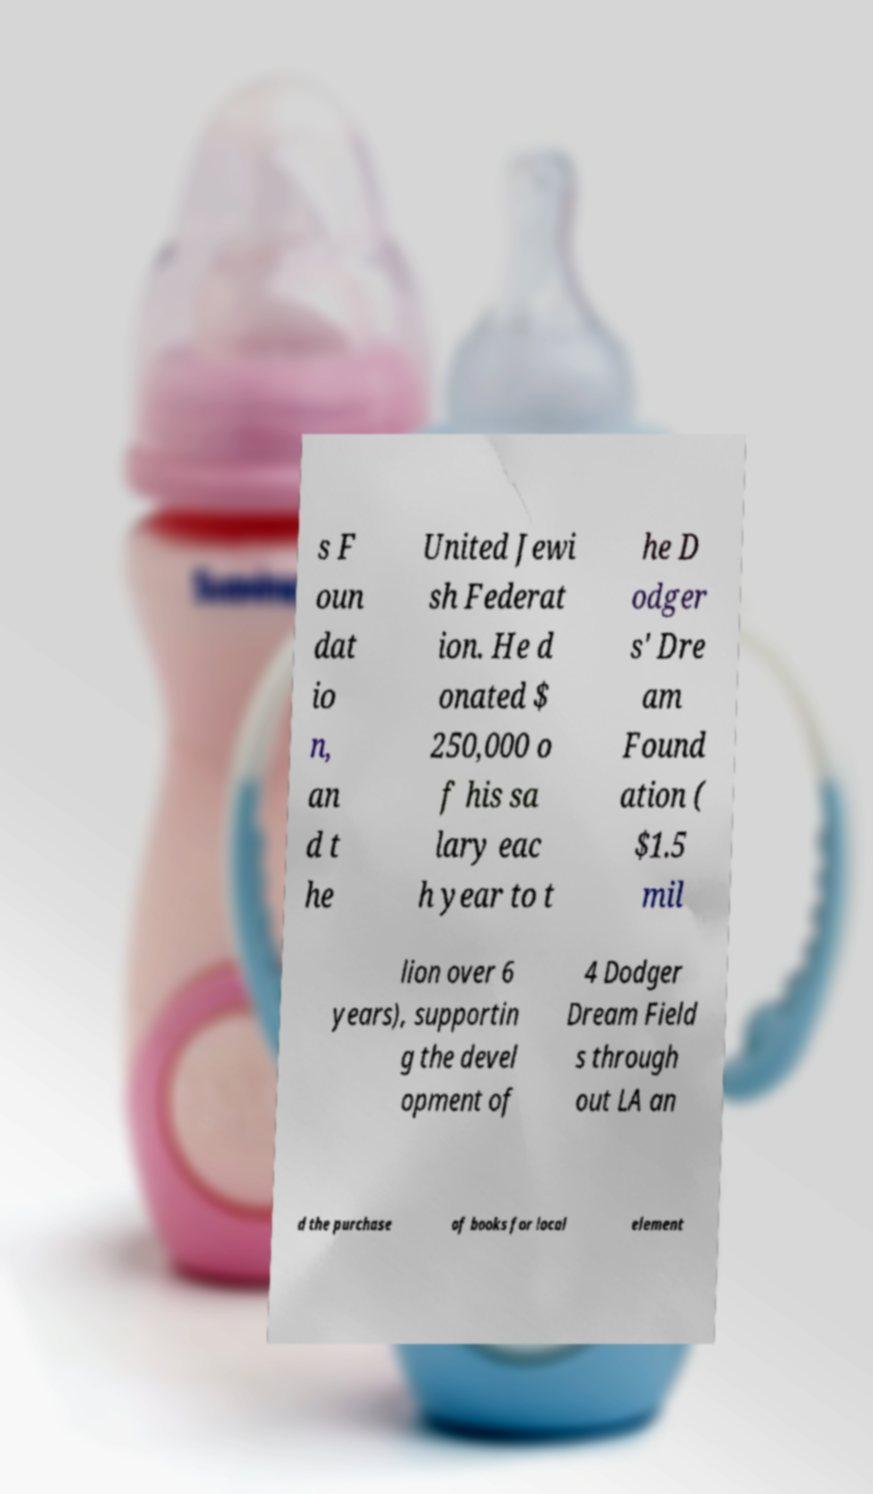Could you assist in decoding the text presented in this image and type it out clearly? s F oun dat io n, an d t he United Jewi sh Federat ion. He d onated $ 250,000 o f his sa lary eac h year to t he D odger s' Dre am Found ation ( $1.5 mil lion over 6 years), supportin g the devel opment of 4 Dodger Dream Field s through out LA an d the purchase of books for local element 